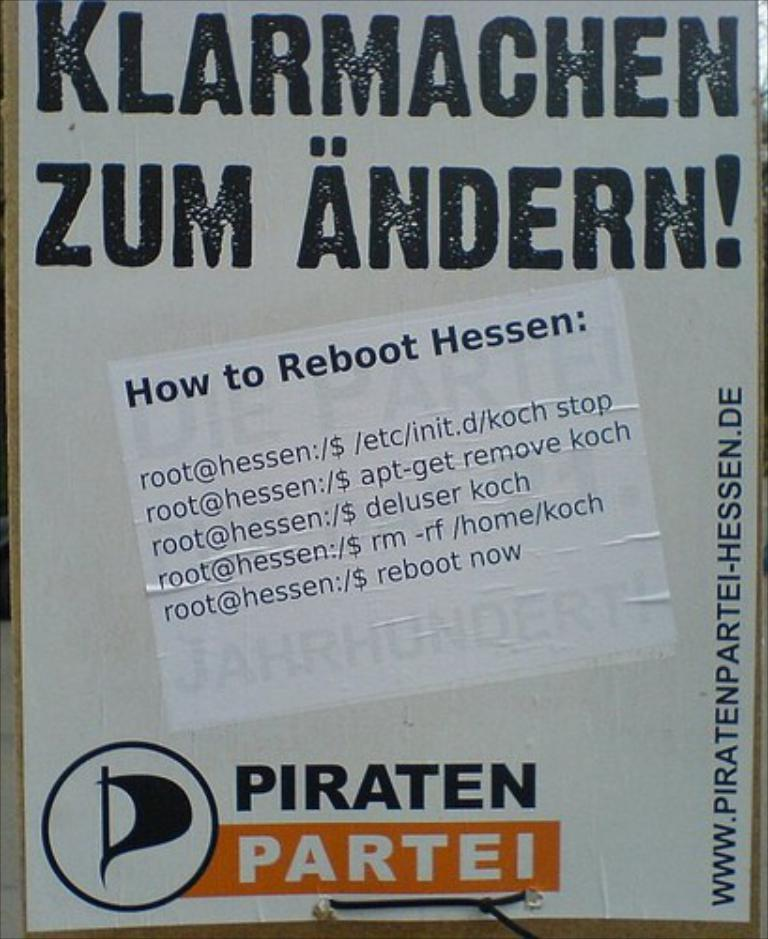<image>
Write a terse but informative summary of the picture. A sign in German has a sticker on it in English with information on how to reboot Hessen. 